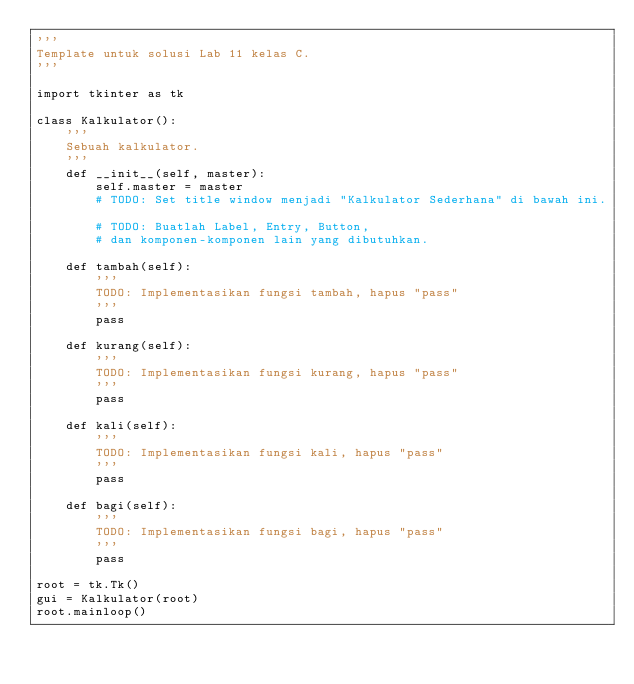Convert code to text. <code><loc_0><loc_0><loc_500><loc_500><_Python_>'''
Template untuk solusi Lab 11 kelas C.
'''

import tkinter as tk

class Kalkulator():
    '''
    Sebuah kalkulator.
    '''
    def __init__(self, master):
        self.master = master
        # TODO: Set title window menjadi "Kalkulator Sederhana" di bawah ini.

        # TODO: Buatlah Label, Entry, Button,
        # dan komponen-komponen lain yang dibutuhkan.

    def tambah(self):
        '''
        TODO: Implementasikan fungsi tambah, hapus "pass"
        '''
        pass

    def kurang(self):
        '''
        TODO: Implementasikan fungsi kurang, hapus "pass"
        '''
        pass

    def kali(self):
        '''
        TODO: Implementasikan fungsi kali, hapus "pass"
        '''
        pass

    def bagi(self):
        '''
        TODO: Implementasikan fungsi bagi, hapus "pass"
        '''
        pass

root = tk.Tk()
gui = Kalkulator(root)
root.mainloop()
</code> 